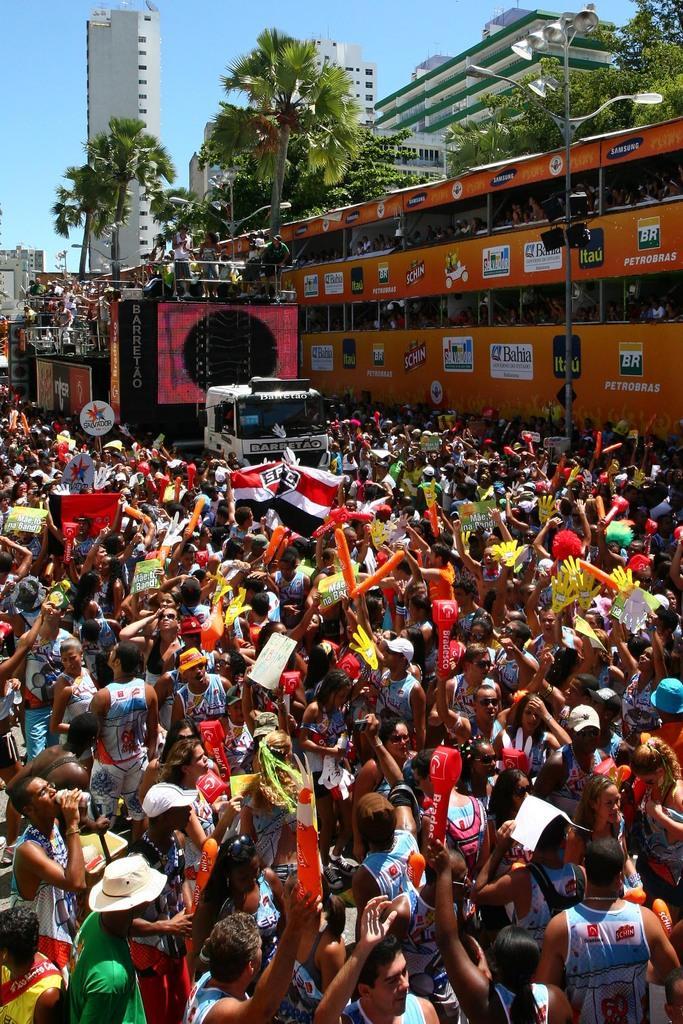Please provide a concise description of this image. In this image we can see some buildings, some vehicles on the road, some trees, one banner with text, some flags, some boards with text, some lights with poles, some people in the vehicles, some people on the vehicle, some people are wearing hats, some people are walking, some people are standing, some people holding objects, some people wearing caps, one man on the left side of the image holding a water bottle and drinking. At the top there is the sky. 